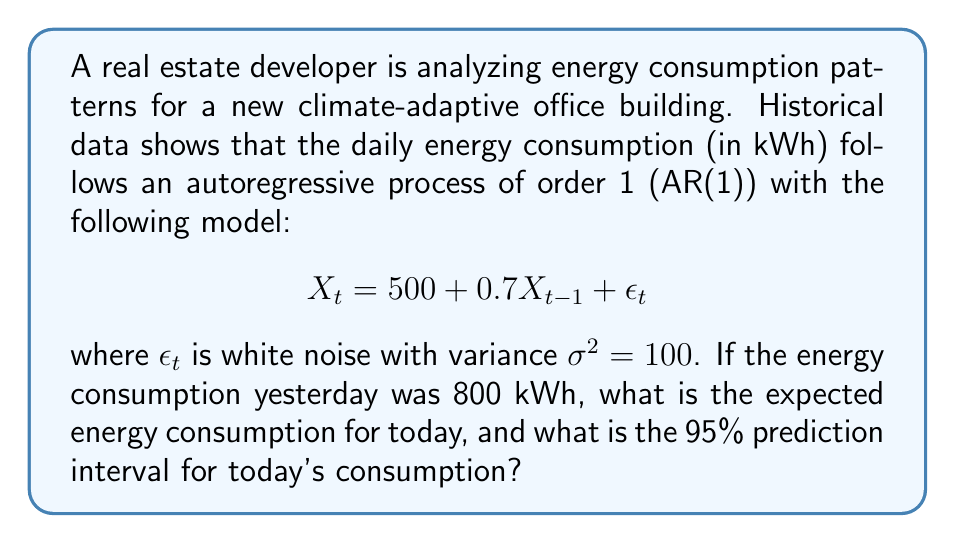Could you help me with this problem? To solve this problem, we'll follow these steps:

1. Calculate the expected energy consumption for today:
   The expected value of $X_t$ given $X_{t-1} = 800$ is:
   $$E[X_t|X_{t-1} = 800] = 500 + 0.7(800) = 500 + 560 = 1060$$

2. Calculate the variance of the forecast error:
   For an AR(1) process, the variance of the one-step-ahead forecast error is equal to the variance of the white noise term, $\sigma^2 = 100$.

3. Calculate the standard deviation of the forecast error:
   $$\sqrt{\sigma^2} = \sqrt{100} = 10$$

4. Determine the 95% prediction interval:
   For a 95% confidence level, we use 1.96 standard deviations (assuming normality).
   The prediction interval is:
   $$1060 \pm 1.96(10)$$
   
   Lower bound: $1060 - 19.6 = 1040.4$
   Upper bound: $1060 + 19.6 = 1079.6$

Therefore, the expected energy consumption for today is 1060 kWh, and the 95% prediction interval is (1040.4 kWh, 1079.6 kWh).
Answer: Expected consumption: 1060 kWh; 95% prediction interval: (1040.4 kWh, 1079.6 kWh) 